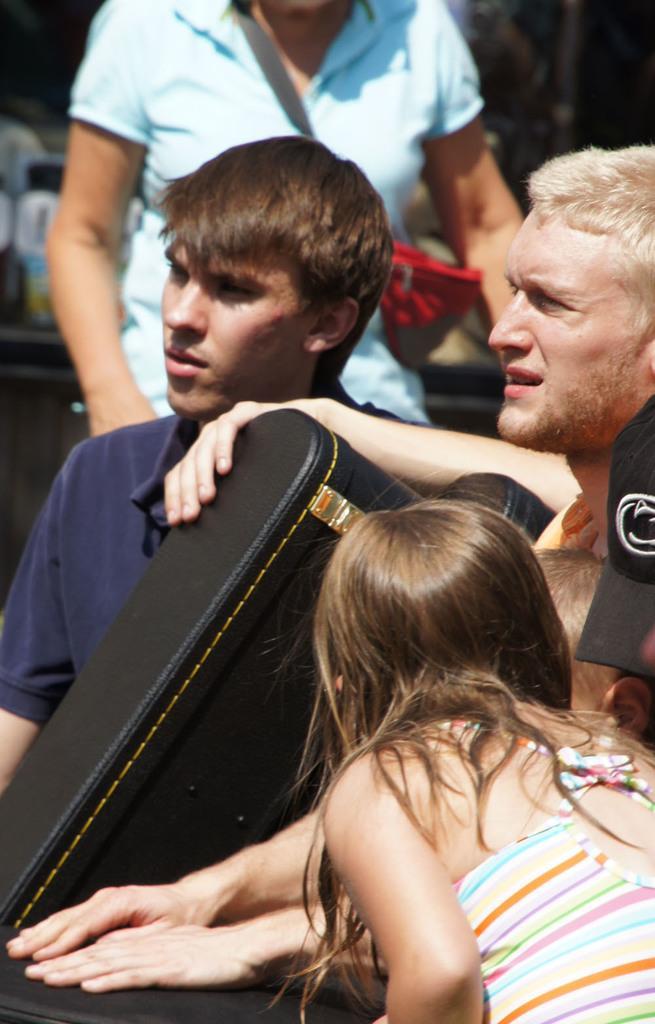Can you describe this image briefly? In the picture we can see three people are standing and holding a bag which is black in color and behind them, we can see a woman standing and wearing a hand bag. 